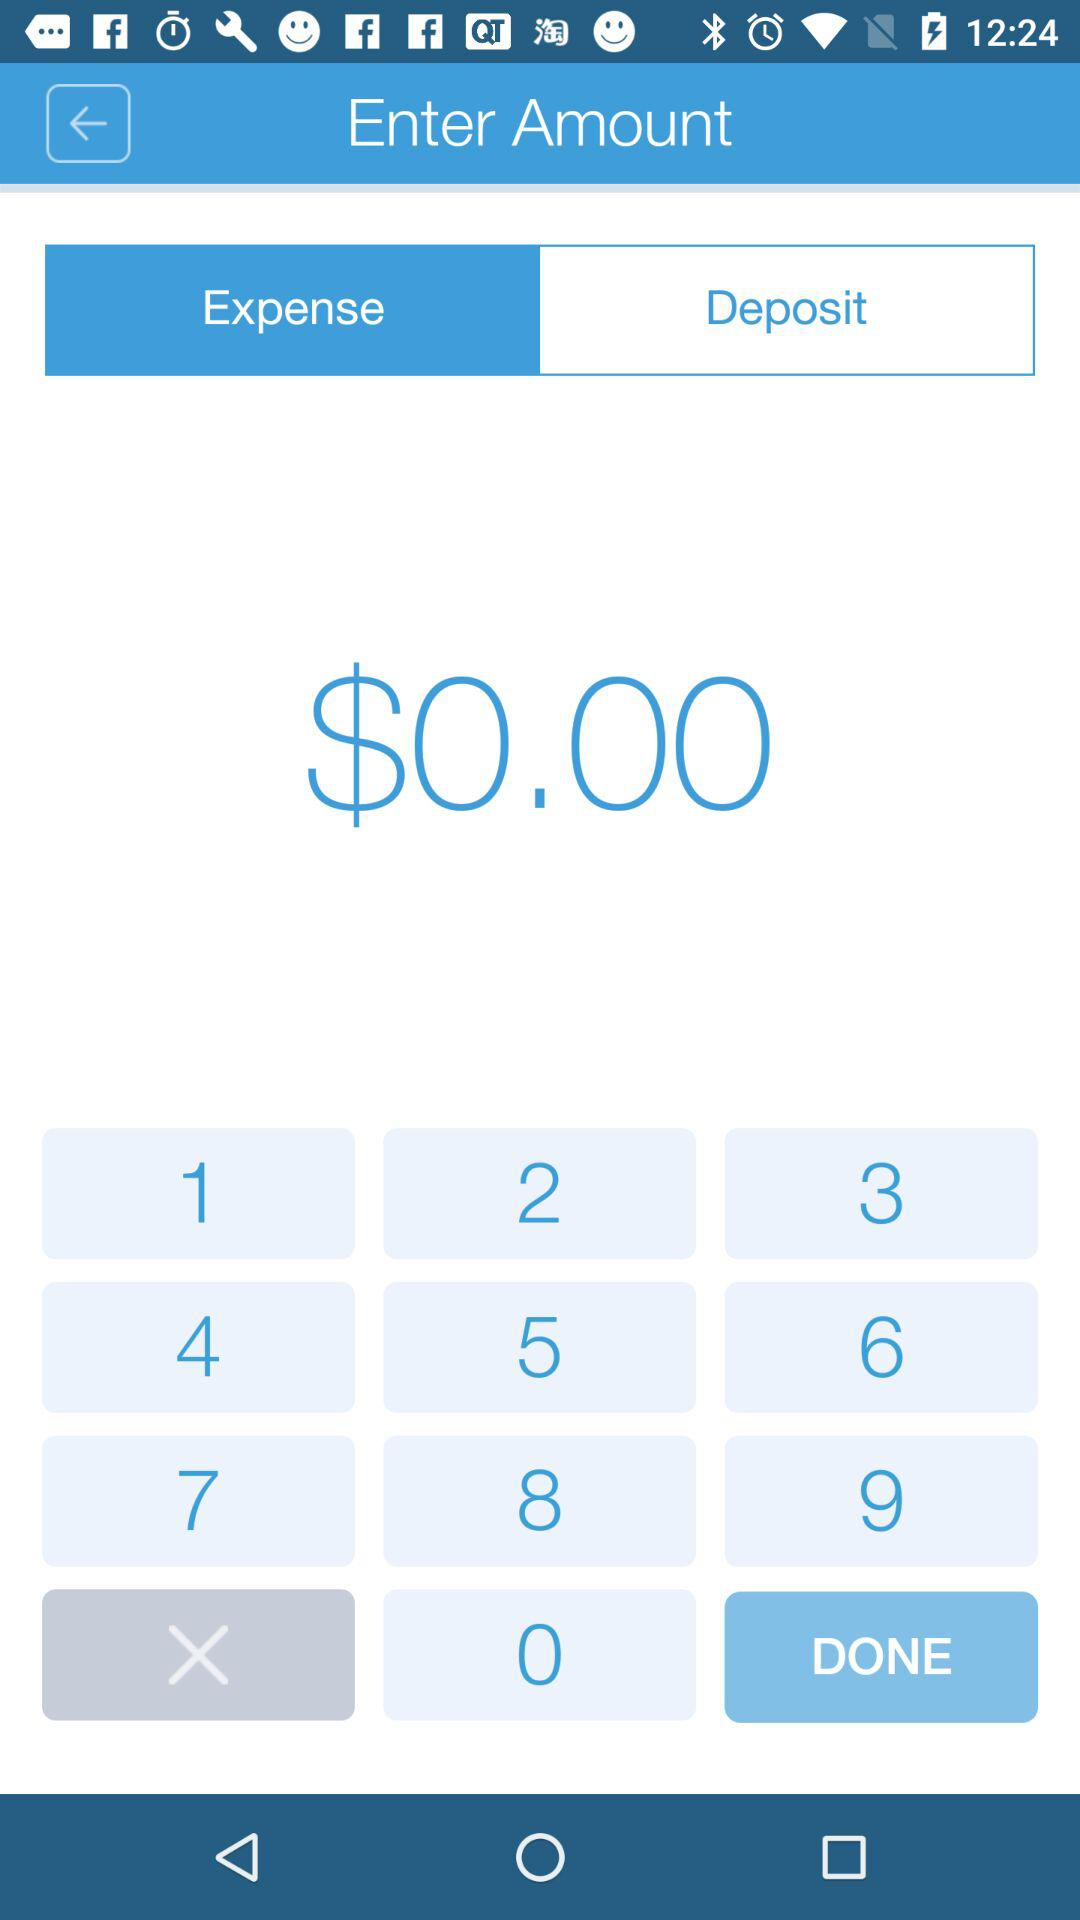What is the amount of the transaction?
Answer the question using a single word or phrase. $0.00 